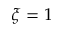<formula> <loc_0><loc_0><loc_500><loc_500>\xi = 1</formula> 